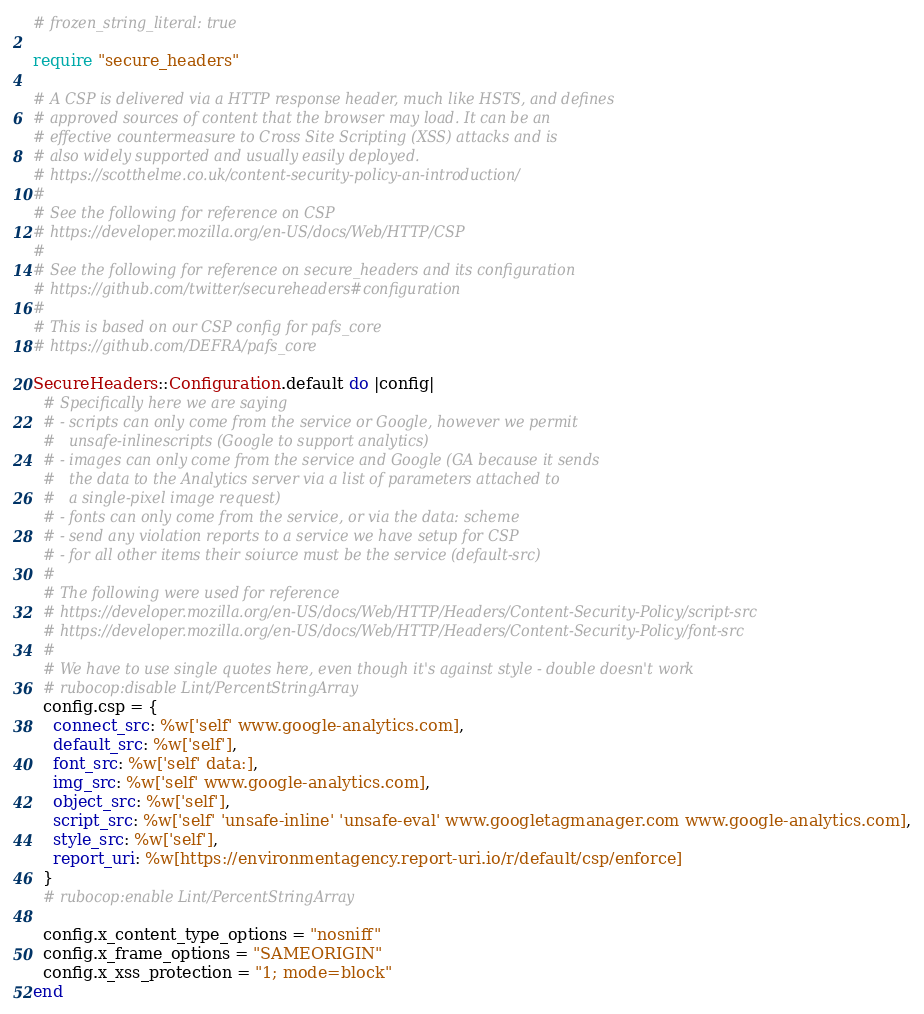Convert code to text. <code><loc_0><loc_0><loc_500><loc_500><_Ruby_># frozen_string_literal: true

require "secure_headers"

# A CSP is delivered via a HTTP response header, much like HSTS, and defines
# approved sources of content that the browser may load. It can be an
# effective countermeasure to Cross Site Scripting (XSS) attacks and is
# also widely supported and usually easily deployed.
# https://scotthelme.co.uk/content-security-policy-an-introduction/
#
# See the following for reference on CSP
# https://developer.mozilla.org/en-US/docs/Web/HTTP/CSP
#
# See the following for reference on secure_headers and its configuration
# https://github.com/twitter/secureheaders#configuration
#
# This is based on our CSP config for pafs_core
# https://github.com/DEFRA/pafs_core

SecureHeaders::Configuration.default do |config|
  # Specifically here we are saying
  # - scripts can only come from the service or Google, however we permit
  #   unsafe-inlinescripts (Google to support analytics)
  # - images can only come from the service and Google (GA because it sends
  #   the data to the Analytics server via a list of parameters attached to
  #   a single-pixel image request)
  # - fonts can only come from the service, or via the data: scheme
  # - send any violation reports to a service we have setup for CSP
  # - for all other items their soiurce must be the service (default-src)
  #
  # The following were used for reference
  # https://developer.mozilla.org/en-US/docs/Web/HTTP/Headers/Content-Security-Policy/script-src
  # https://developer.mozilla.org/en-US/docs/Web/HTTP/Headers/Content-Security-Policy/font-src
  #
  # We have to use single quotes here, even though it's against style - double doesn't work
  # rubocop:disable Lint/PercentStringArray
  config.csp = {
    connect_src: %w['self' www.google-analytics.com],
    default_src: %w['self'],
    font_src: %w['self' data:],
    img_src: %w['self' www.google-analytics.com],
    object_src: %w['self'],
    script_src: %w['self' 'unsafe-inline' 'unsafe-eval' www.googletagmanager.com www.google-analytics.com],
    style_src: %w['self'],
    report_uri: %w[https://environmentagency.report-uri.io/r/default/csp/enforce]
  }
  # rubocop:enable Lint/PercentStringArray

  config.x_content_type_options = "nosniff"
  config.x_frame_options = "SAMEORIGIN"
  config.x_xss_protection = "1; mode=block"
end
</code> 